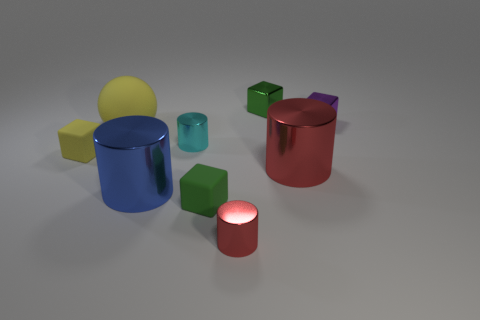Subtract 1 cylinders. How many cylinders are left? 3 Subtract all red cubes. Subtract all green balls. How many cubes are left? 4 Subtract all cubes. How many objects are left? 5 Subtract 0 brown cylinders. How many objects are left? 9 Subtract all tiny yellow rubber cylinders. Subtract all tiny yellow matte things. How many objects are left? 8 Add 5 big blue metal objects. How many big blue metal objects are left? 6 Add 1 rubber things. How many rubber things exist? 4 